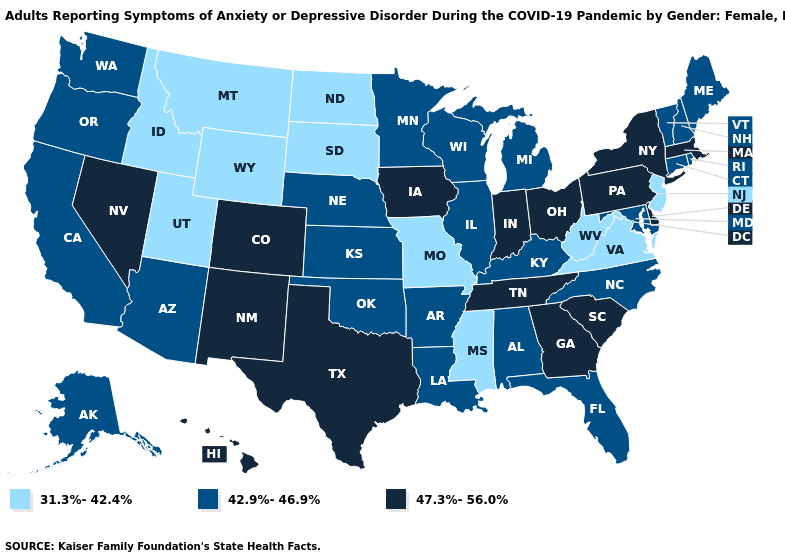What is the highest value in states that border Connecticut?
Quick response, please. 47.3%-56.0%. What is the highest value in the USA?
Write a very short answer. 47.3%-56.0%. Does South Carolina have the highest value in the USA?
Answer briefly. Yes. Name the states that have a value in the range 31.3%-42.4%?
Be succinct. Idaho, Mississippi, Missouri, Montana, New Jersey, North Dakota, South Dakota, Utah, Virginia, West Virginia, Wyoming. What is the value of Ohio?
Quick response, please. 47.3%-56.0%. Which states have the lowest value in the USA?
Quick response, please. Idaho, Mississippi, Missouri, Montana, New Jersey, North Dakota, South Dakota, Utah, Virginia, West Virginia, Wyoming. Name the states that have a value in the range 42.9%-46.9%?
Concise answer only. Alabama, Alaska, Arizona, Arkansas, California, Connecticut, Florida, Illinois, Kansas, Kentucky, Louisiana, Maine, Maryland, Michigan, Minnesota, Nebraska, New Hampshire, North Carolina, Oklahoma, Oregon, Rhode Island, Vermont, Washington, Wisconsin. What is the highest value in the USA?
Keep it brief. 47.3%-56.0%. Does Kentucky have a higher value than Idaho?
Give a very brief answer. Yes. Does Ohio have the highest value in the MidWest?
Keep it brief. Yes. What is the value of Wisconsin?
Concise answer only. 42.9%-46.9%. Does the map have missing data?
Answer briefly. No. Name the states that have a value in the range 31.3%-42.4%?
Quick response, please. Idaho, Mississippi, Missouri, Montana, New Jersey, North Dakota, South Dakota, Utah, Virginia, West Virginia, Wyoming. Does the first symbol in the legend represent the smallest category?
Concise answer only. Yes. Name the states that have a value in the range 47.3%-56.0%?
Short answer required. Colorado, Delaware, Georgia, Hawaii, Indiana, Iowa, Massachusetts, Nevada, New Mexico, New York, Ohio, Pennsylvania, South Carolina, Tennessee, Texas. 